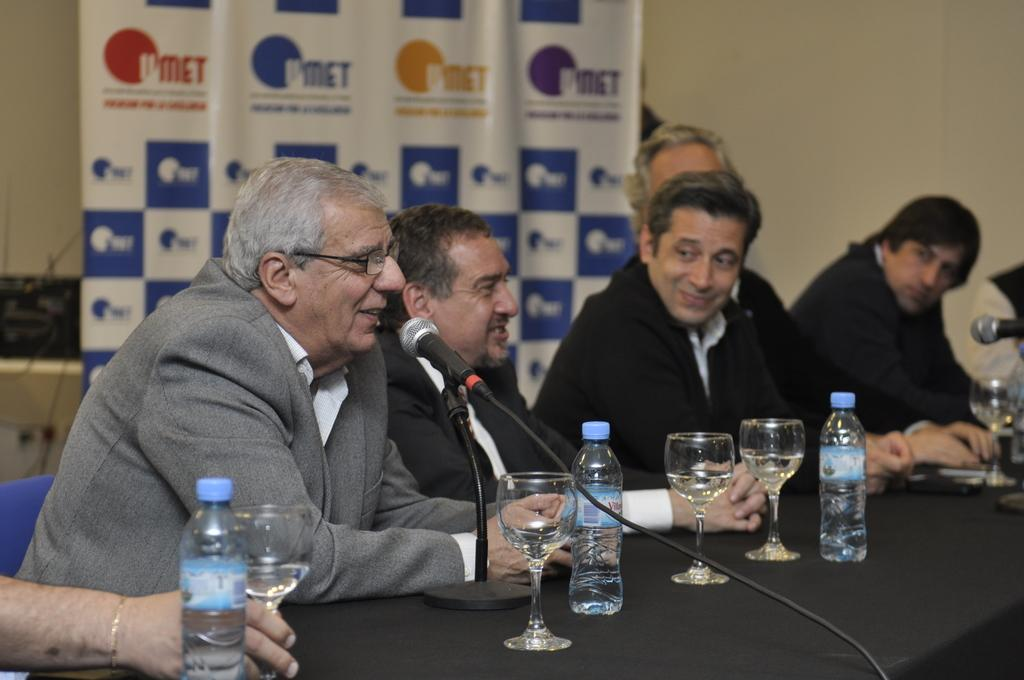How many people are visible in the image? There are many persons sitting in the image. What is in front of the persons? There is a table in front of the persons. What can be seen on the table? There are glasses, bottles, mics, and a mic stand on the table. What is visible in the background of the image? There is a banner and a wall in the background of the image. What type of linen is being used to cover the table in the image? There is no linen visible in the image; the table is not covered. What is the chance of winning a prize in the image? There is no indication of a prize or a game in the image, so it's not possible to determine the chance of winning a prize. 